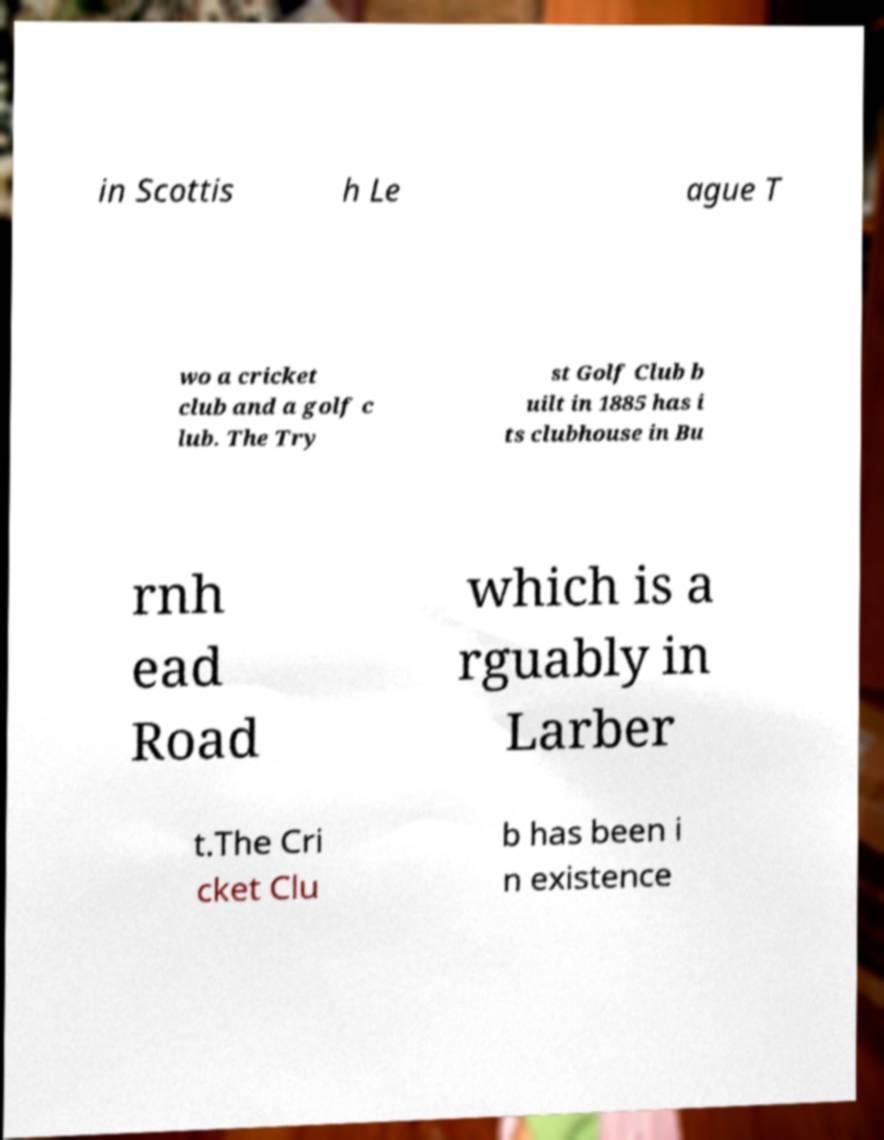For documentation purposes, I need the text within this image transcribed. Could you provide that? in Scottis h Le ague T wo a cricket club and a golf c lub. The Try st Golf Club b uilt in 1885 has i ts clubhouse in Bu rnh ead Road which is a rguably in Larber t.The Cri cket Clu b has been i n existence 